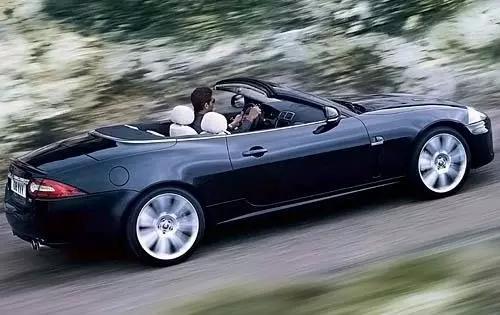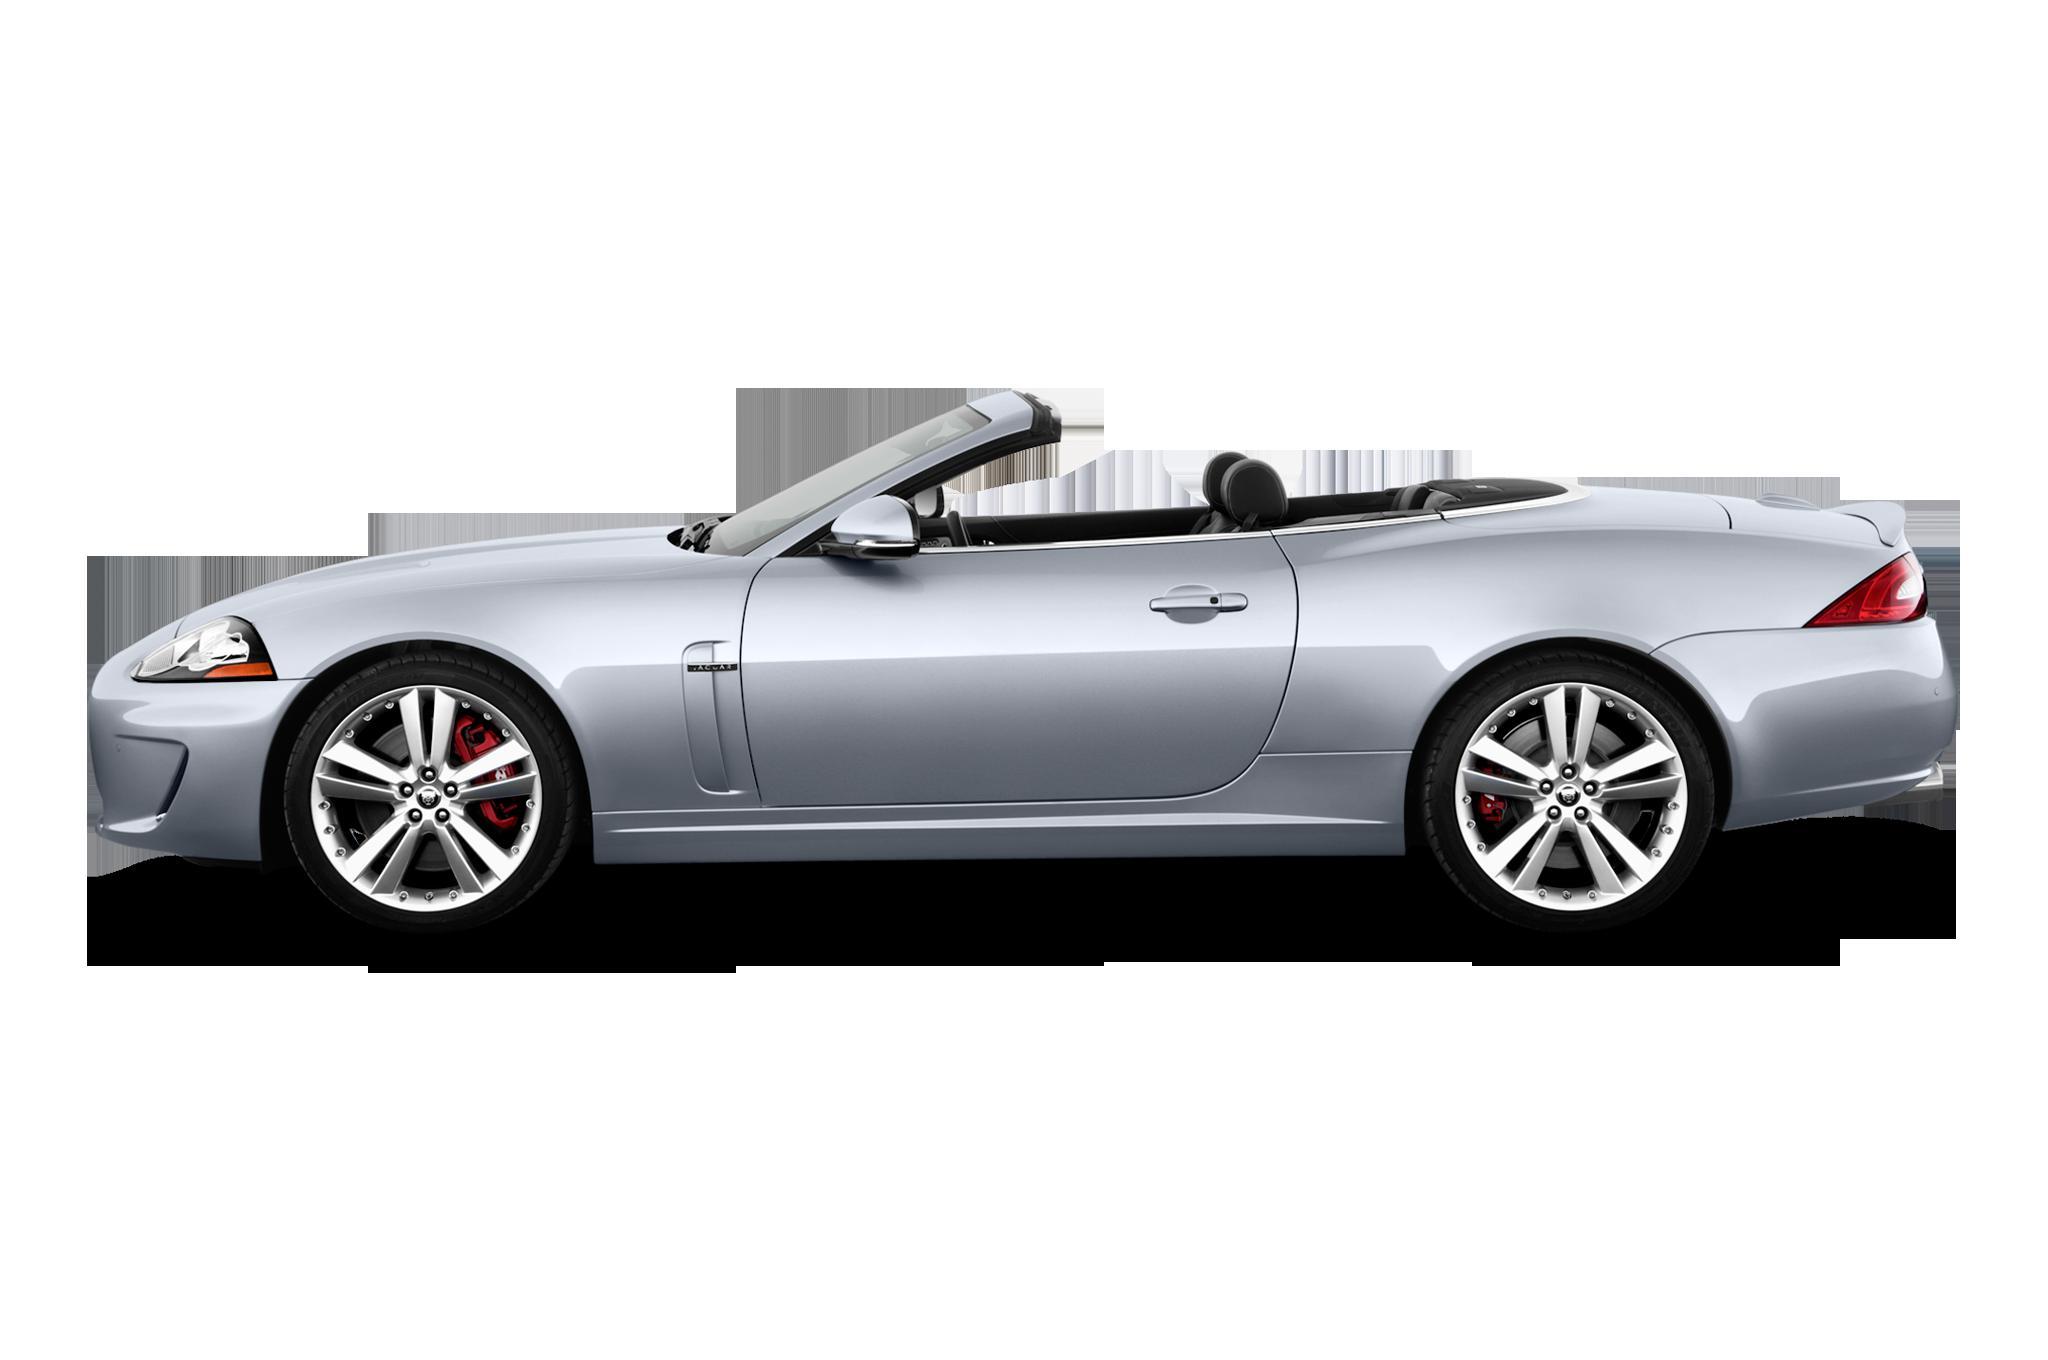The first image is the image on the left, the second image is the image on the right. Considering the images on both sides, is "There is a black convertible on a paved street with its top down" valid? Answer yes or no. Yes. The first image is the image on the left, the second image is the image on the right. For the images shown, is this caption "there are solid white convertibles" true? Answer yes or no. No. 